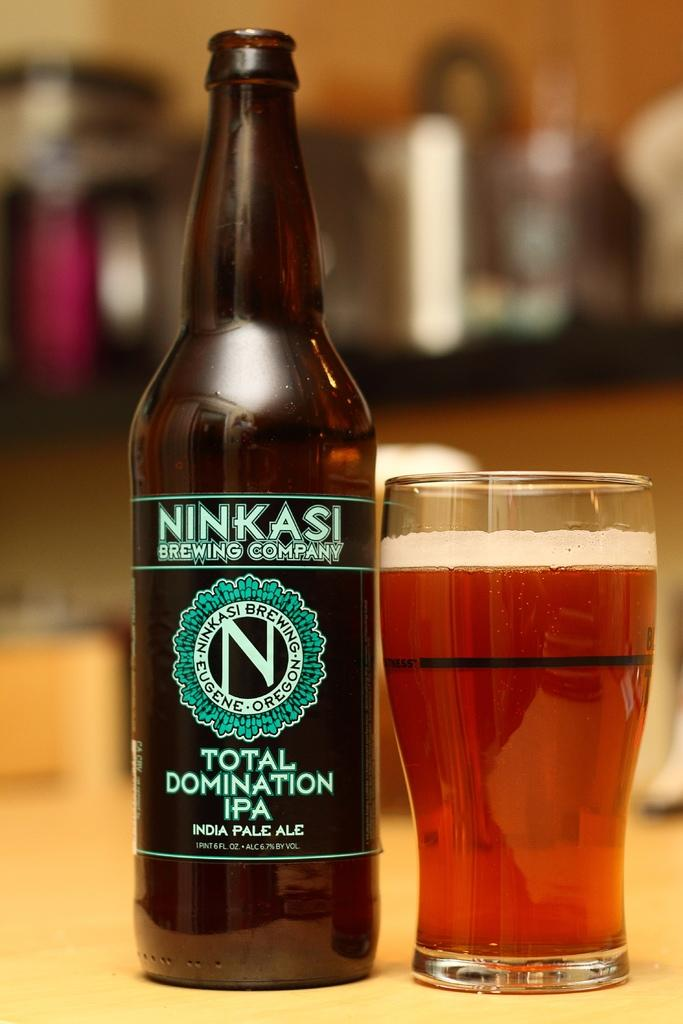<image>
Relay a brief, clear account of the picture shown. An alcohol bottle with Ninkasi brewing company and a glass of beer beside it. 